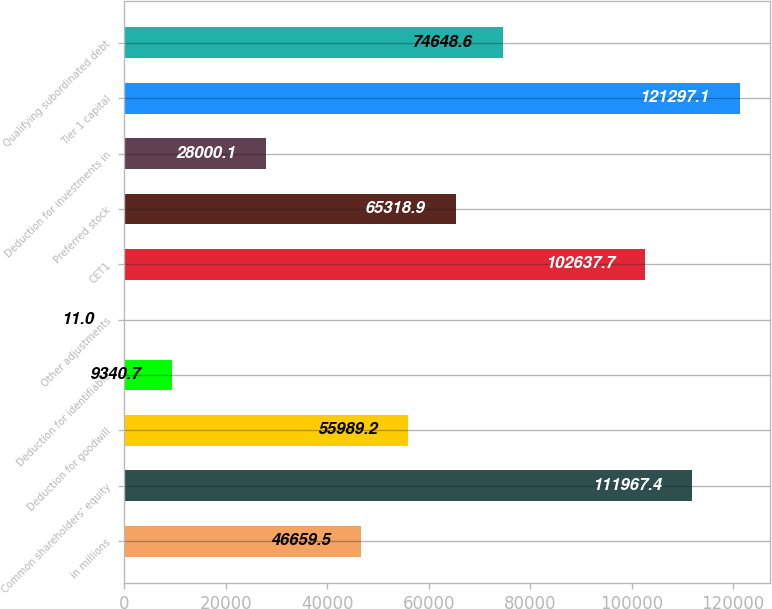Convert chart to OTSL. <chart><loc_0><loc_0><loc_500><loc_500><bar_chart><fcel>in millions<fcel>Common shareholders' equity<fcel>Deduction for goodwill<fcel>Deduction for identifiable<fcel>Other adjustments<fcel>CET1<fcel>Preferred stock<fcel>Deduction for investments in<fcel>Tier 1 capital<fcel>Qualifying subordinated debt<nl><fcel>46659.5<fcel>111967<fcel>55989.2<fcel>9340.7<fcel>11<fcel>102638<fcel>65318.9<fcel>28000.1<fcel>121297<fcel>74648.6<nl></chart> 